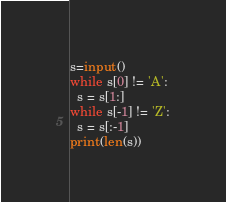Convert code to text. <code><loc_0><loc_0><loc_500><loc_500><_Python_>s=input()
while s[0] != 'A':
  s = s[1:]
while s[-1] != 'Z':
  s = s[:-1]
print(len(s))
</code> 